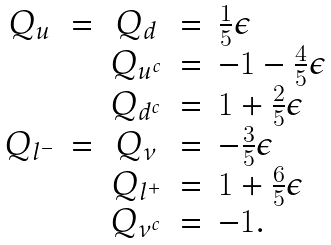Convert formula to latex. <formula><loc_0><loc_0><loc_500><loc_500>\begin{array} { c c c c l } Q _ { u } & = & Q _ { d } & = & \frac { 1 } { 5 } \epsilon \\ & & Q _ { u ^ { c } } & = & - 1 - \frac { 4 } { 5 } \epsilon \\ & & Q _ { d ^ { c } } & = & 1 + \frac { 2 } { 5 } \epsilon \\ Q _ { l ^ { - } } & = & Q _ { \nu } & = & - \frac { 3 } { 5 } \epsilon \\ & & Q _ { l ^ { + } } & = & 1 + \frac { 6 } { 5 } \epsilon \\ & & Q _ { \nu ^ { c } } & = & - 1 . \\ \end{array}</formula> 